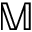<formula> <loc_0><loc_0><loc_500><loc_500>{ \mathbb { M } }</formula> 